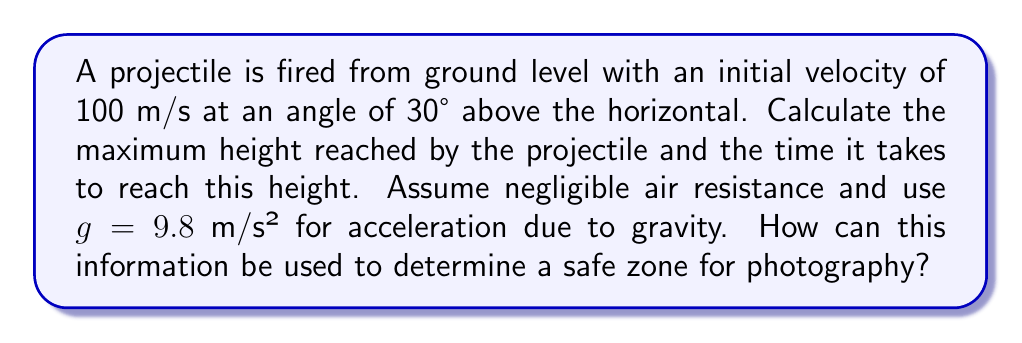Help me with this question. To solve this problem, we'll use the equations of motion for projectile motion. Let's break it down step-by-step:

1. Vertical component of initial velocity:
   $v_{0y} = v_0 \sin \theta = 100 \cdot \sin 30° = 50$ m/s

2. Time to reach maximum height:
   At the highest point, the vertical velocity is zero.
   $$v_y = v_{0y} - gt = 0$$
   $$t = \frac{v_{0y}}{g} = \frac{50}{9.8} \approx 5.10$ seconds

3. Maximum height:
   Using the equation $y = v_{0y}t - \frac{1}{2}gt^2$
   $$h_{max} = 50 \cdot 5.10 - \frac{1}{2} \cdot 9.8 \cdot (5.10)^2 \approx 127.55$ meters

To determine a safe zone for photography:
- The maximum height of 127.55 meters indicates the vertical range of the projectile.
- The time to reach maximum height (5.10 seconds) is half the total flight time.
- A safe zone would be beyond the total horizontal distance traveled by the projectile.

Horizontal distance:
$$x = v_{0x}t = (v_0 \cos \theta)(2t) = (100 \cos 30°)(2 \cdot 5.10) \approx 883.17$ meters

Therefore, a safe zone for photography would be beyond 883.17 meters from the launch point, considering both the vertical and horizontal range of the projectile.
Answer: Maximum height: 127.55 m; Time to reach maximum height: 5.10 s; Safe zone: > 883.17 m from launch point 